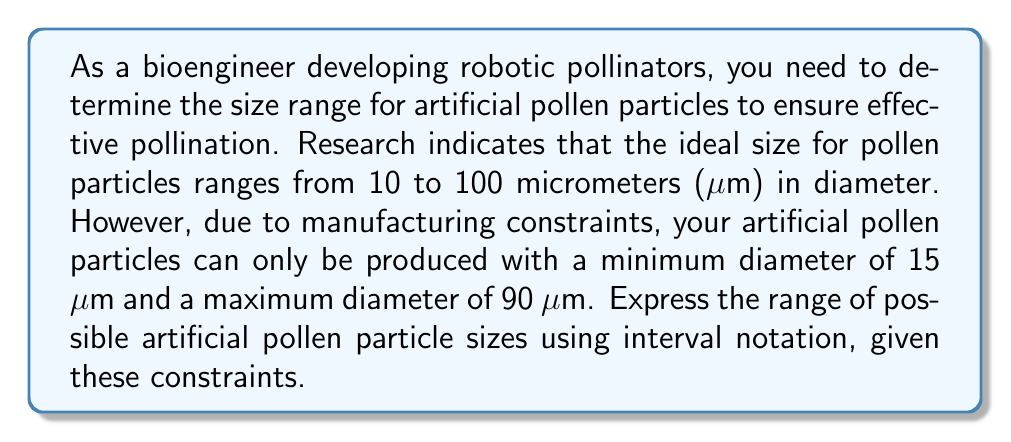Solve this math problem. To solve this problem, we need to consider both the ideal size range and the manufacturing constraints:

1. Ideal size range: 10 to 100 μm
2. Manufacturing constraints: 15 to 90 μm

We need to find the intersection of these two ranges to determine the actual possible size range for the artificial pollen particles.

Let's compare the lower bounds:
$\max(10, 15) = 15$ μm

Now, let's compare the upper bounds:
$\min(100, 90) = 90$ μm

Therefore, the actual range of possible sizes for the artificial pollen particles is from 15 μm to 90 μm.

In interval notation, we represent this range as a closed interval since both endpoints are included:

$[15, 90]$

This notation means that the artificial pollen particles can have any diameter greater than or equal to 15 μm and less than or equal to 90 μm.
Answer: $[15, 90]$ 